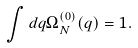Convert formula to latex. <formula><loc_0><loc_0><loc_500><loc_500>\int d q \Omega ^ { ( 0 ) } _ { N } ( q ) = 1 .</formula> 